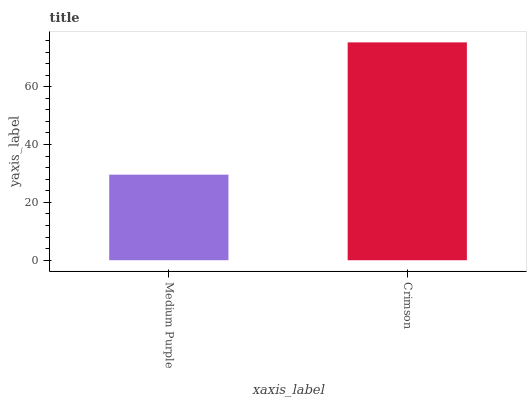Is Crimson the minimum?
Answer yes or no. No. Is Crimson greater than Medium Purple?
Answer yes or no. Yes. Is Medium Purple less than Crimson?
Answer yes or no. Yes. Is Medium Purple greater than Crimson?
Answer yes or no. No. Is Crimson less than Medium Purple?
Answer yes or no. No. Is Crimson the high median?
Answer yes or no. Yes. Is Medium Purple the low median?
Answer yes or no. Yes. Is Medium Purple the high median?
Answer yes or no. No. Is Crimson the low median?
Answer yes or no. No. 